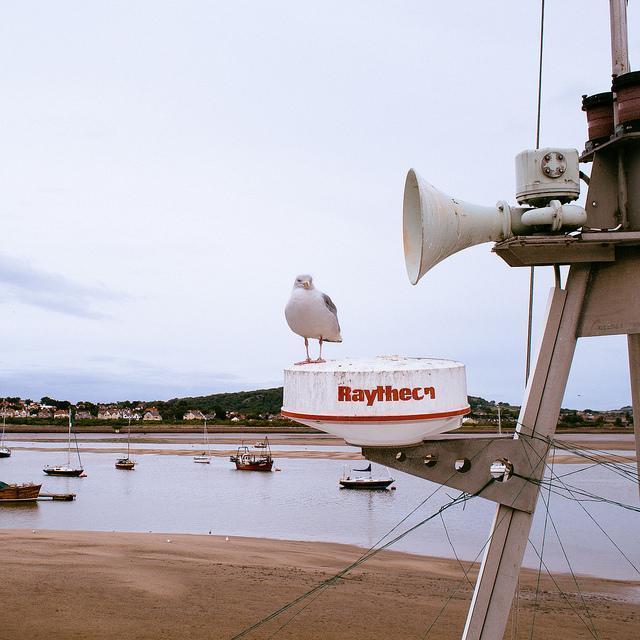How many boats are in the picture?
Give a very brief answer. 7. 